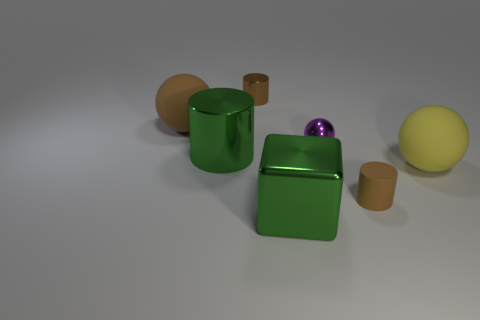What number of tiny purple metal things are there?
Keep it short and to the point. 1. Is the brown ball made of the same material as the brown cylinder that is in front of the green shiny cylinder?
Ensure brevity in your answer.  Yes. What number of green objects are either small cylinders or big things?
Give a very brief answer. 2. There is a sphere that is the same material as the large yellow object; what size is it?
Make the answer very short. Large. What number of small brown things are the same shape as the yellow matte object?
Ensure brevity in your answer.  0. Are there more purple things that are left of the cube than rubber cylinders to the right of the large yellow matte thing?
Provide a short and direct response. No. There is a large shiny cylinder; does it have the same color as the cylinder that is in front of the yellow matte object?
Your response must be concise. No. There is a brown object that is the same size as the green cylinder; what material is it?
Make the answer very short. Rubber. How many things are big brown matte balls or objects behind the large yellow sphere?
Offer a terse response. 4. There is a rubber cylinder; does it have the same size as the thing in front of the small brown matte cylinder?
Provide a succinct answer. No. 